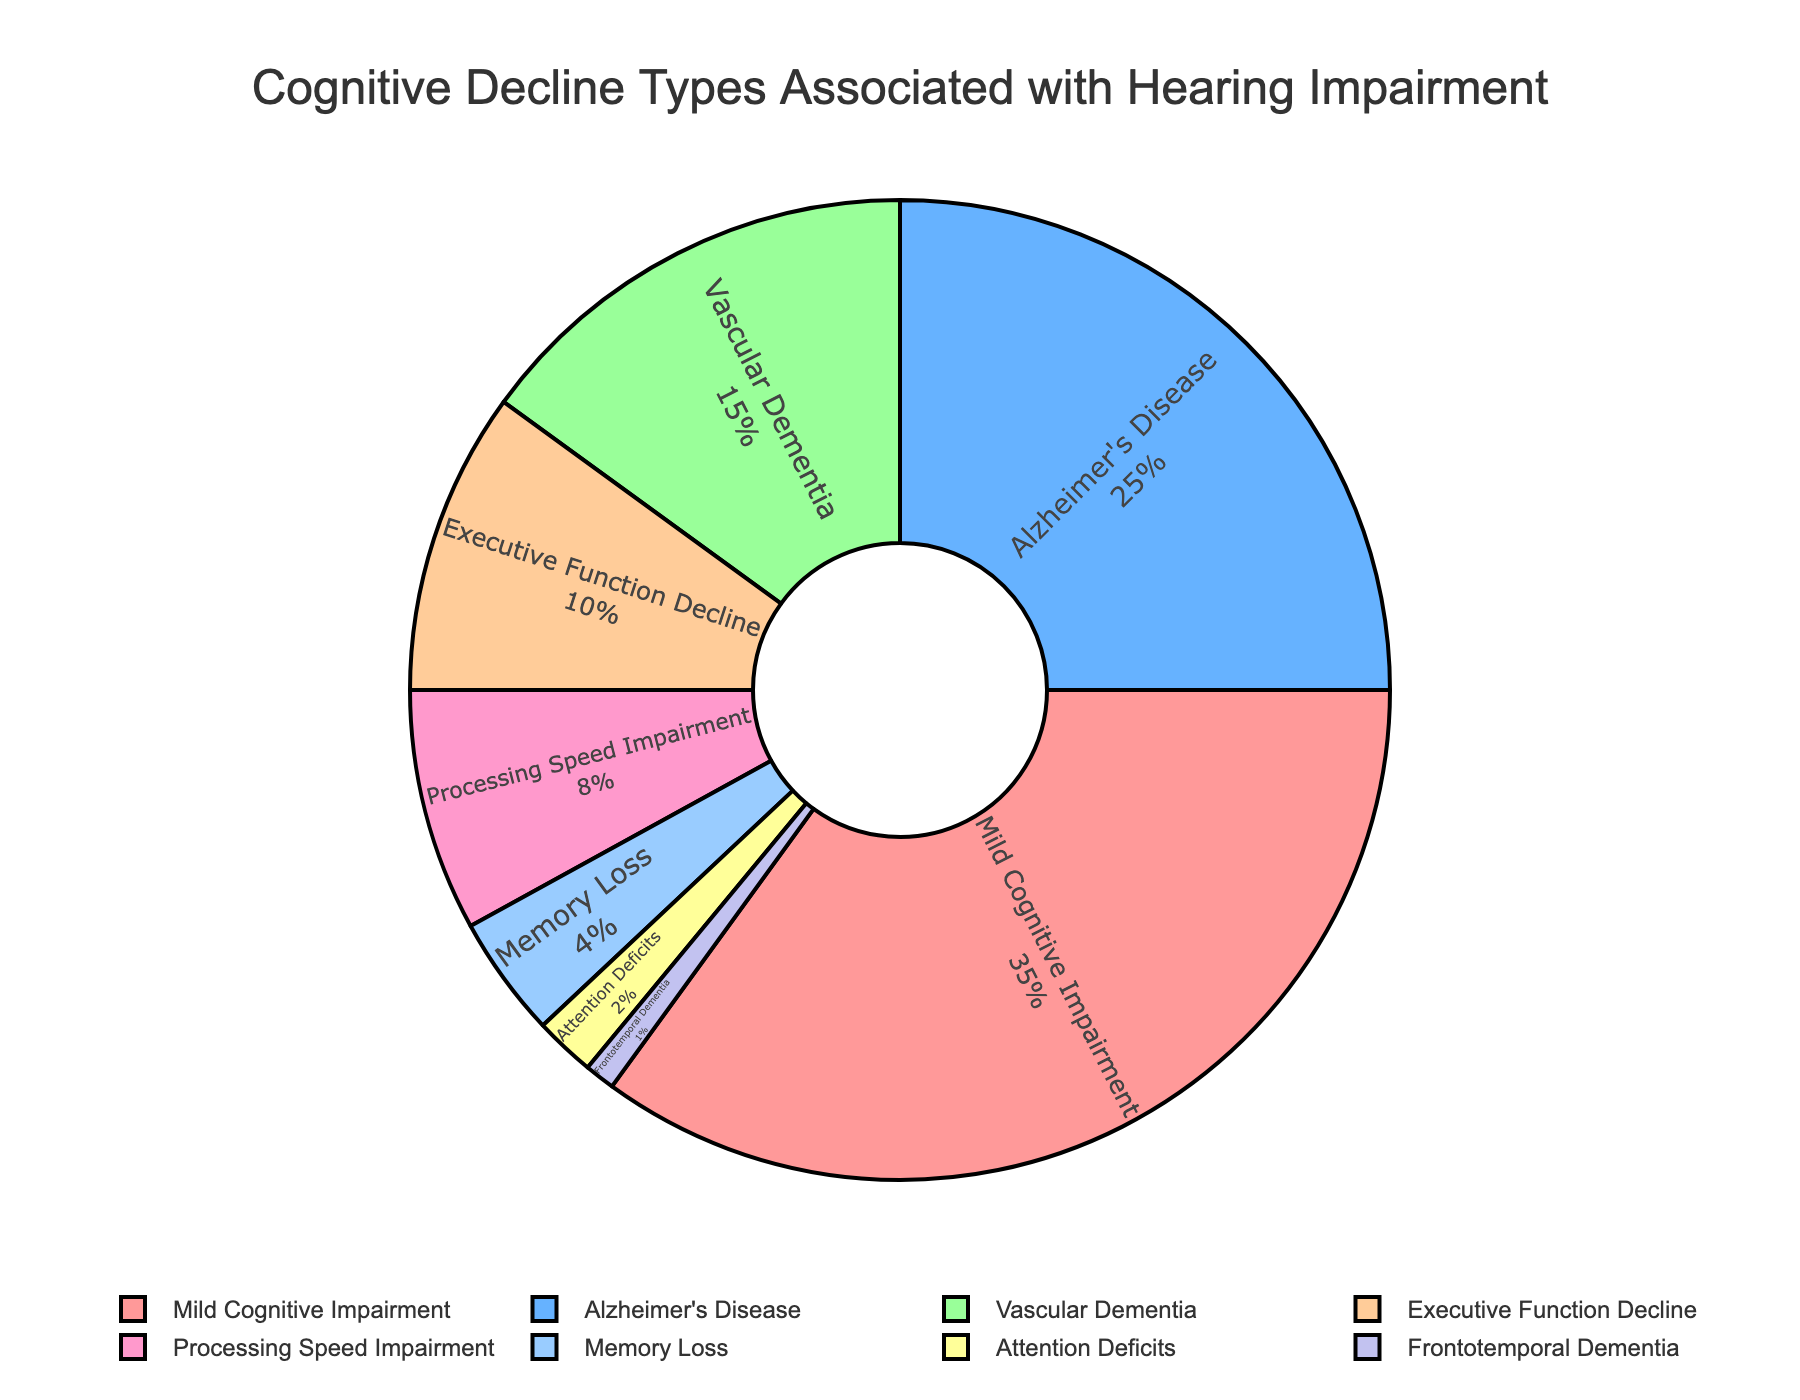Which type of cognitive decline is most associated with hearing impairment? The pie chart shows that 'Mild Cognitive Impairment' has the largest segment. The percentage for this type is the highest at 35%.
Answer: Mild Cognitive Impairment What is the second most common type of cognitive decline associated with hearing impairment according to the pie chart? The segment labeled 'Alzheimer's Disease' is second largest, representing 25% of cases.
Answer: Alzheimer's Disease How much more prevalent is mild cognitive impairment compared to vascular dementia? Mild Cognitive Impairment is 35% and Vascular Dementia is 15%, so the difference is 35% - 15% = 20%.
Answer: 20% What are the combined percentages of the least common cognitive decline types: memory loss, attention deficits, and frontotemporal dementia? The percentages are 4% for memory loss, 2% for attention deficits, and 1% for frontotemporal dementia. Adding them up, 4% + 2% + 1% = 7%.
Answer: 7% Which cognitive decline type is associated with the smallest percentage? The segment labeled 'Frontotemporal Dementia' is the smallest, representing 1% of the total.
Answer: Frontotemporal Dementia How much larger in percentage is the Executive Function Decline compared to Processing Speed Impairment? Executive Function Decline is 10% and Processing Speed Impairment is 8%, so the difference is 10% - 8% = 2%.
Answer: 2% What fraction of the pie chart represents Alzheimer's Disease and Executive Function Decline combined? Alzheimer's Disease is 25% and Executive Function Decline is 10%, so combined they are 25% + 10% = 35%, which corresponds to 35/100 or 7/20 fraction of the pie chart.
Answer: 7/20 If the total number of patients studied were 200, how many patients suffer from Processing Speed Impairment? Processing Speed Impairment is 8%. So, the number of patients is 200 * 0.08 = 16.
Answer: 16 Which cognitive decline type category has a darker blue shade? By the visual cue, the Cognitive Decline Type linked with the color close to darker blue is 'Vascular Dementia'.
Answer: Vascular Dementia 